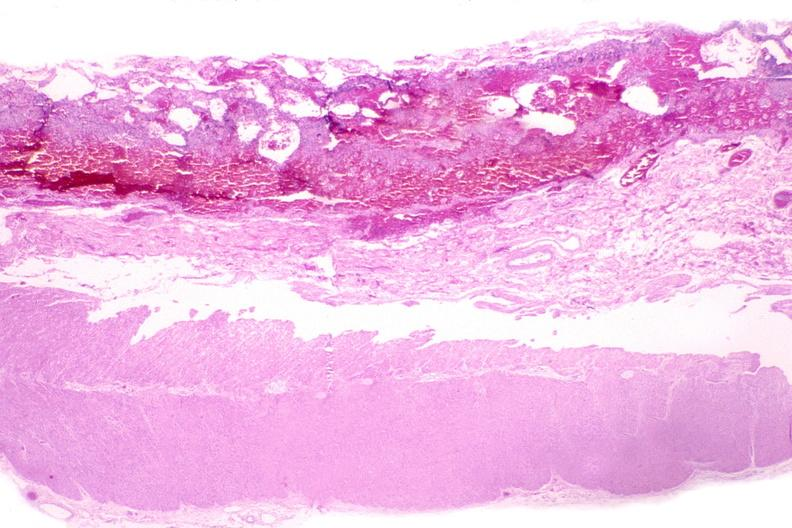what is present?
Answer the question using a single word or phrase. Gastrointestinal 